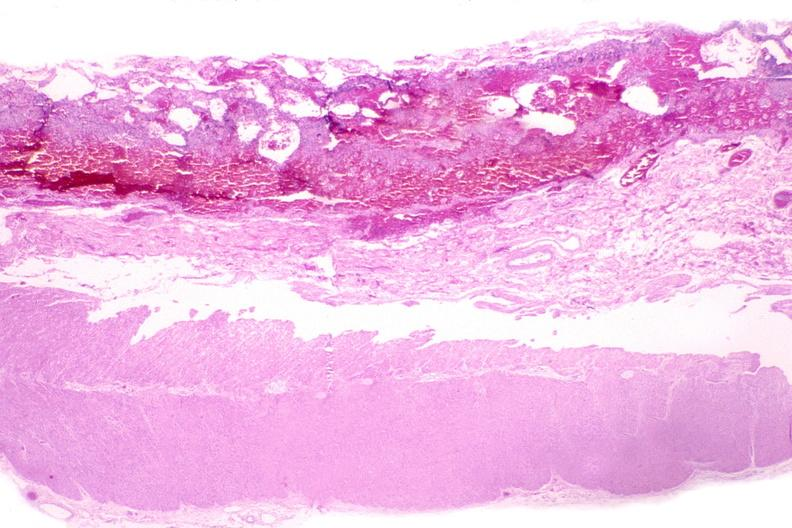what is present?
Answer the question using a single word or phrase. Gastrointestinal 